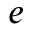Convert formula to latex. <formula><loc_0><loc_0><loc_500><loc_500>e</formula> 